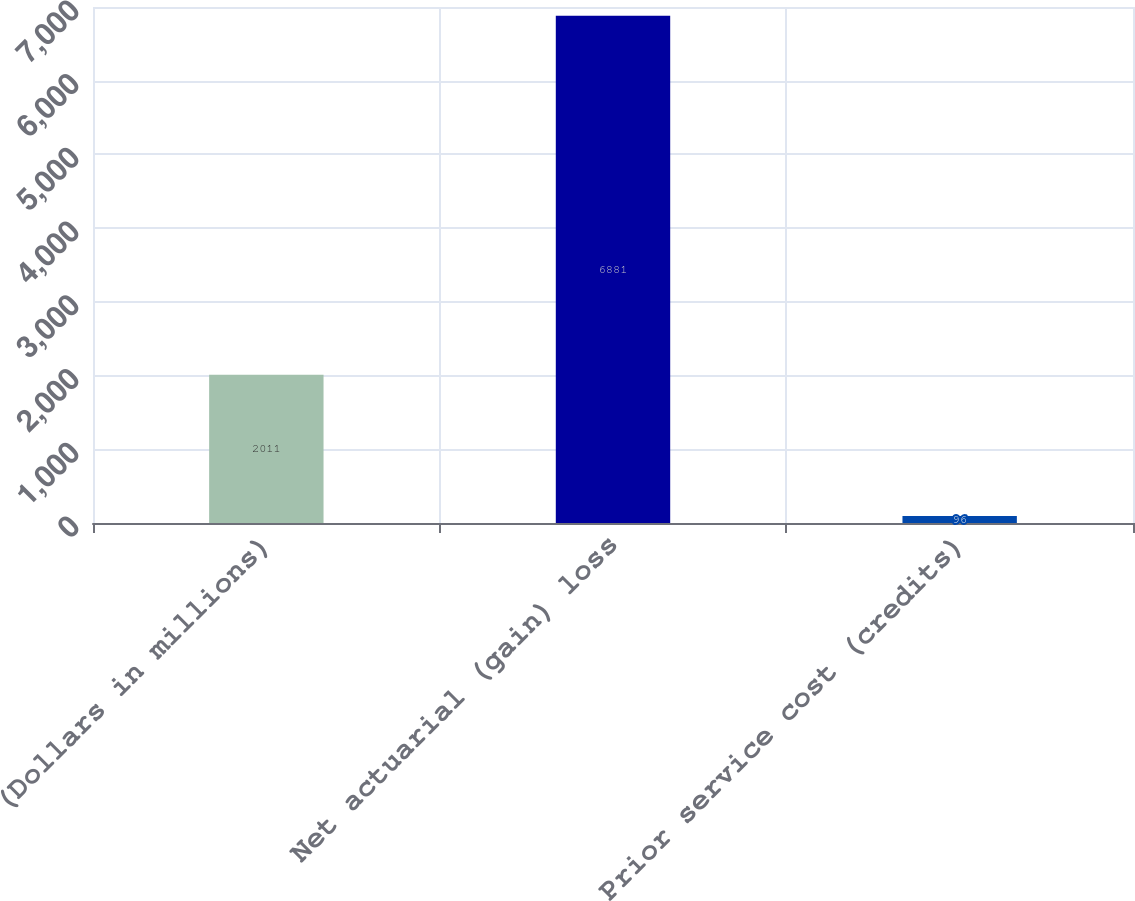<chart> <loc_0><loc_0><loc_500><loc_500><bar_chart><fcel>(Dollars in millions)<fcel>Net actuarial (gain) loss<fcel>Prior service cost (credits)<nl><fcel>2011<fcel>6881<fcel>96<nl></chart> 